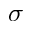<formula> <loc_0><loc_0><loc_500><loc_500>\sigma</formula> 